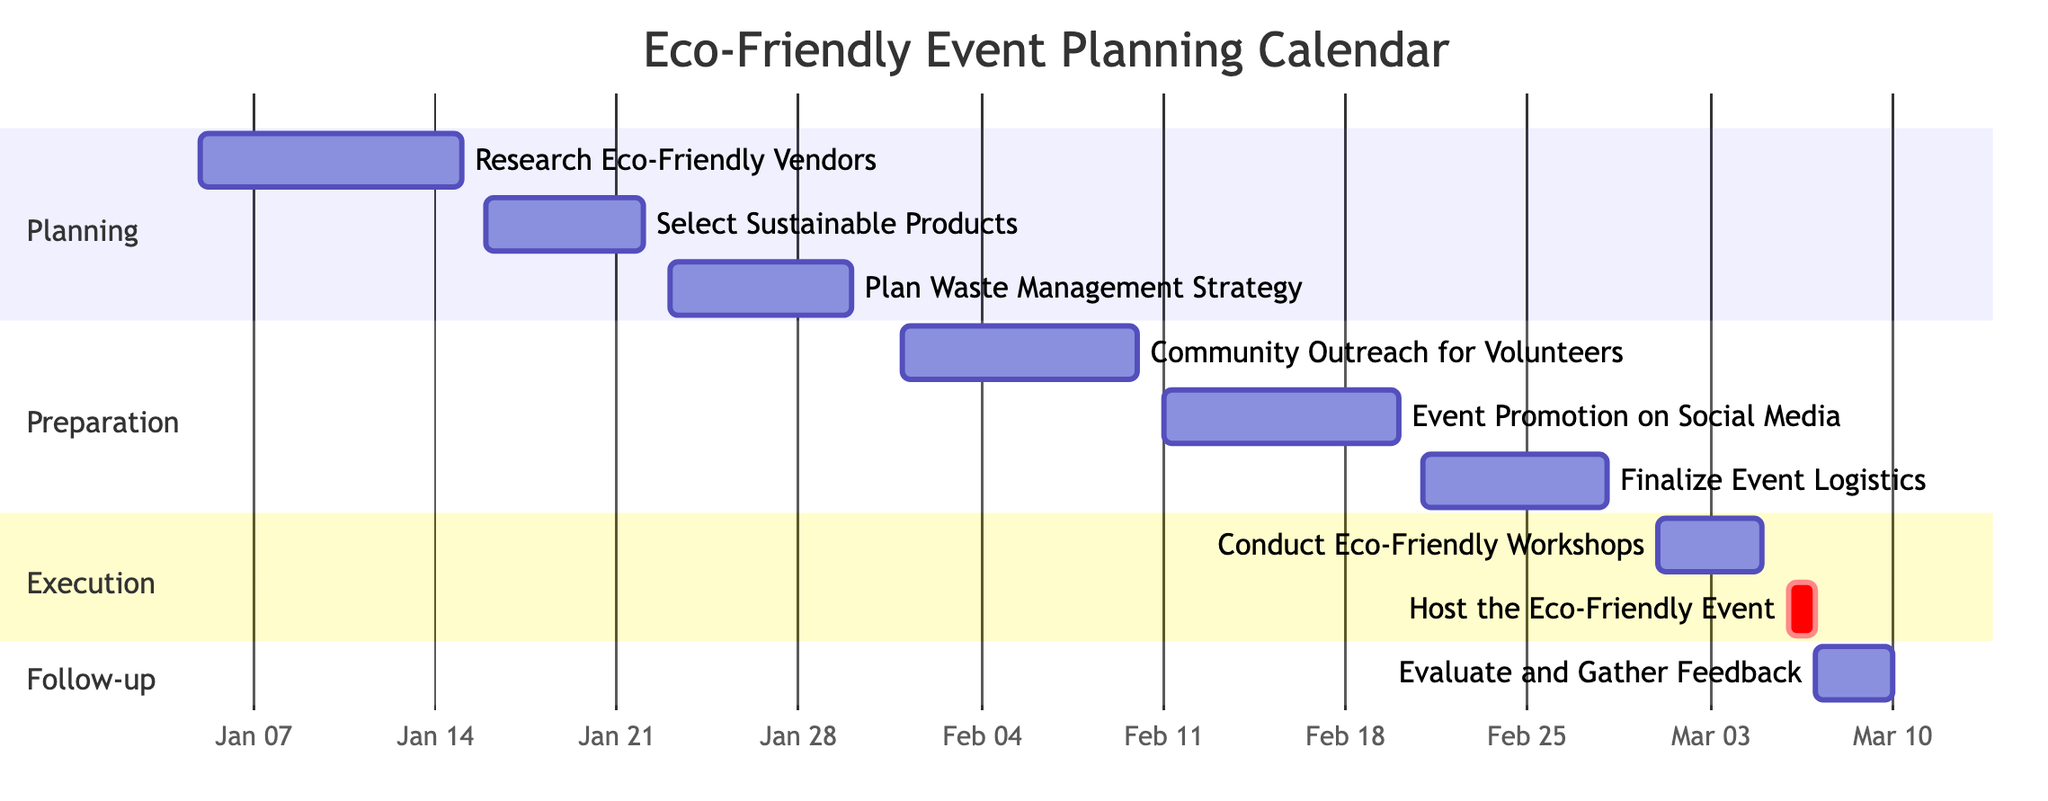What is the duration of the event "Research Eco-Friendly Vendors"? The event "Research Eco-Friendly Vendors" has a specified duration of 10 days, as indicated directly in the diagram next to the event name.
Answer: 10 days When does the event "Host the Eco-Friendly Event" take place? The event "Host the Eco-Friendly Event" is marked in the Gantt chart and specifically shows the date as March 6, 2024, which is its only date listed.
Answer: March 6, 2024 How many days are allocated for "Event Promotion on Social Media"? By checking the Gantt chart, "Event Promotion on Social Media" shows a duration of 9 days listed next to its name, which directly answers the question regarding its time allocation.
Answer: 9 days What are the two main sections of the preparation phase? The preparation phase includes "Community Outreach for Volunteers" and "Event Promotion on Social Media," both of which are listed in the preparation section of the Gantt chart.
Answer: Community Outreach for Volunteers, Event Promotion on Social Media Which event has the shortest duration? Upon reviewing the events, "Host the Eco-Friendly Event" is the only event that lasts for 1 day, which makes it the shortest duration event in the schedule.
Answer: 1 day Which event immediately follows "Finalize Event Logistics"? The event that follows "Finalize Event Logistics" in the schedule is "Conduct Eco-Friendly Workshops," as identified by examining the sequence of entries in the Gantt chart.
Answer: Conduct Eco-Friendly Workshops What is the total number of events in the Gantt chart? There are 9 events listed in total, which can be counted directly from the event entries in the diagram.
Answer: 9 events How many days is planned for the event evaluation phase? The evaluation phase, which includes "Evaluate and Gather Feedback," is allocated 3 days as indicated in the Gantt chart near the event name.
Answer: 3 days Which task is critical in the execution phase? The task "Host the Eco-Friendly Event" is marked as critical in the execution phase, which is indicated by its specific notation in the Gantt chart.
Answer: Host the Eco-Friendly Event 